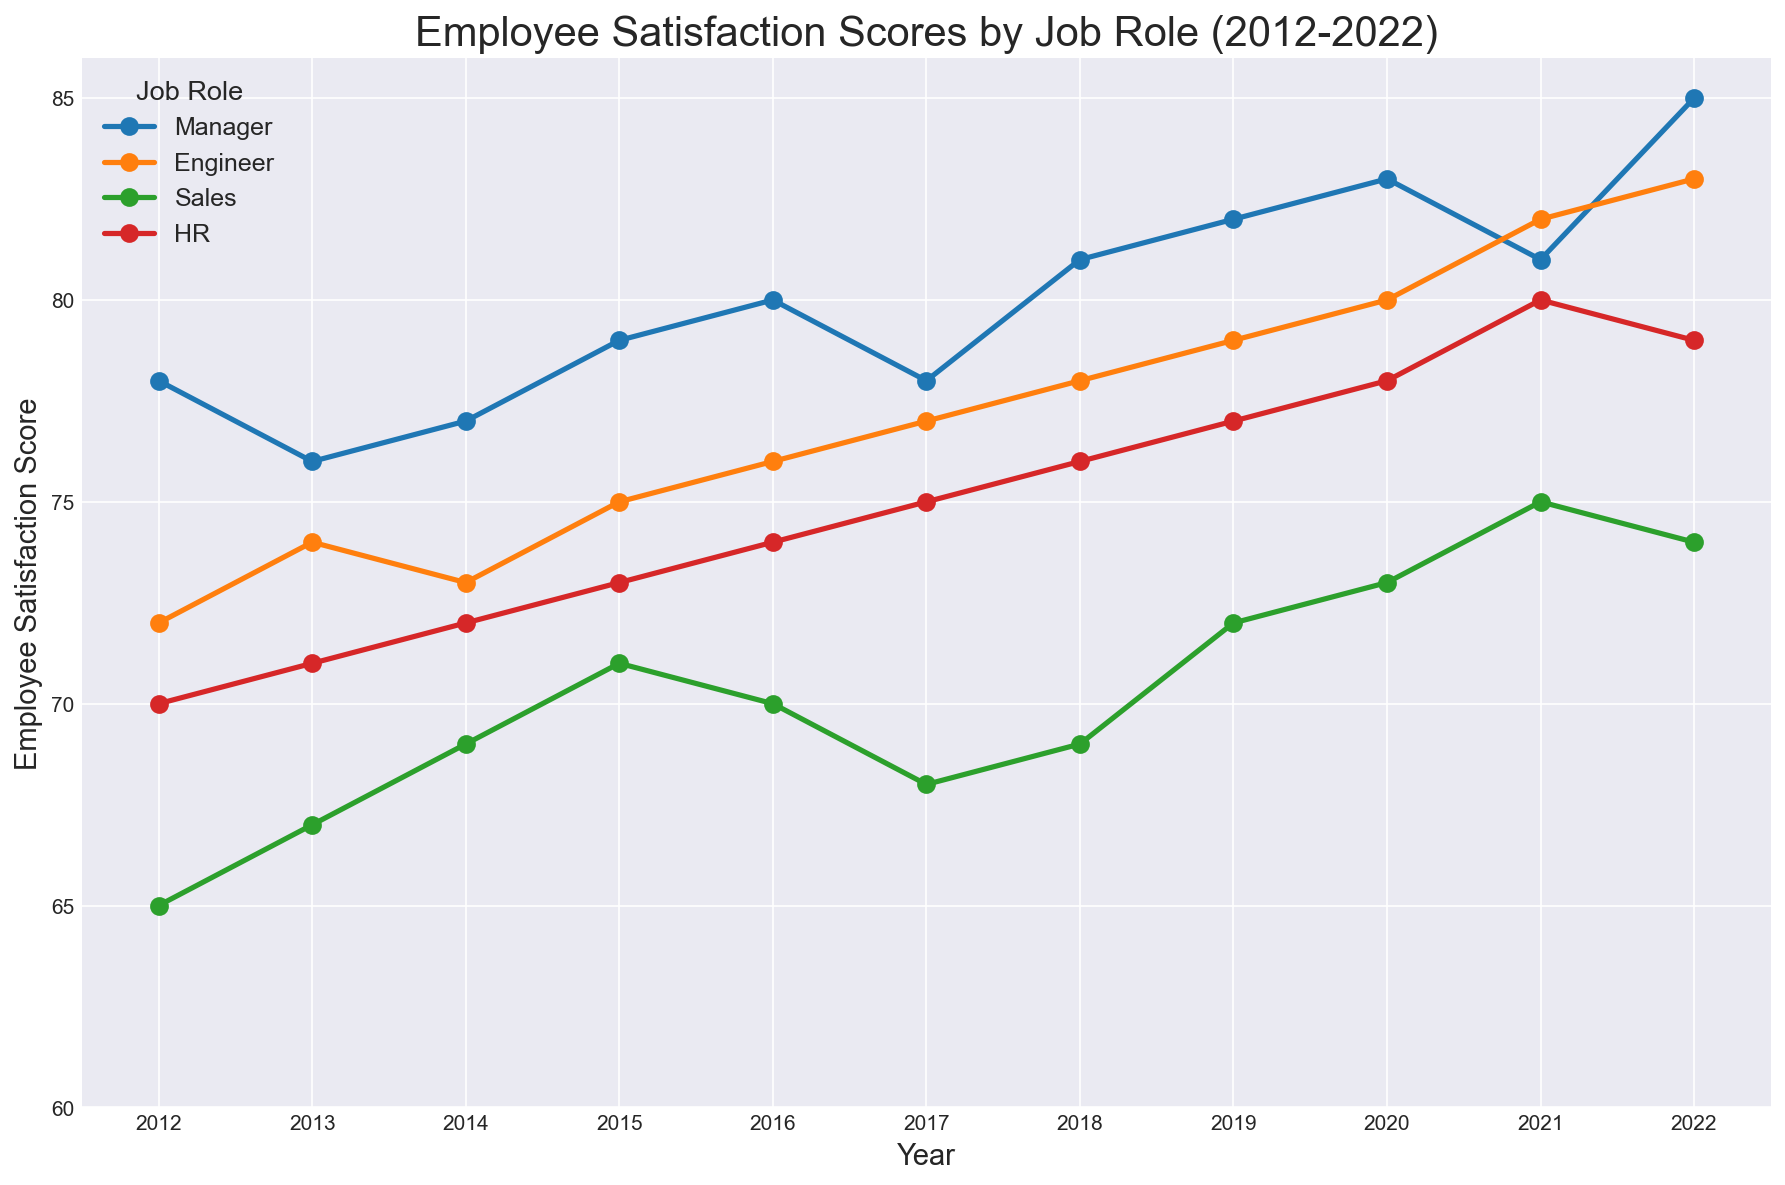What is the overall trend in Employee Satisfaction Scores for Engineers from 2012 to 2022? The visual trend line for Engineers shows a gradual increase in Employee Satisfaction Scores over the years from 72 in 2012 to 83 in 2022.
Answer: Gradual increase In which year did HR employees reach their highest satisfaction score? Observing the line, the highest point for HR employees is in the year 2021 with a score of 80.
Answer: 2021 Which job role had the highest Employee Satisfaction Score in 2022? The figure shows the Manager role closely reaching 85 in 2022, which is higher than any other job roles.
Answer: Manager How did the Employee Satisfaction Scores for Sales change from 2019 to 2022? The scores of Sales changed over the years, starting at 72 in 2019, increasing briefly to 73 in 2020, then rising again to 75 in 2021, but then dropped to 74 in 2022.
Answer: Increased initially, then dropped slightly By how much did the Employee Satisfaction Score for Engineers increase from 2017 to 2020? In 2017, the Engineers’ score is 77, and in 2020, it is 80. The increase is calculated as 80 - 77 = 3.
Answer: 3 Which job role showed the most significant improvement in Employee Satisfaction Scores from 2012 to 2022? By observing the slopes, Managers showed the most significant improvement from 78 in 2012 to 85 in 2022, which is an increase of 7.
Answer: Manager In what year did Sales employees experience a dip in their satisfaction score, and what was the score? Sales employees had a dip in their Employee Satisfaction Score in 2017, where the score decreased to 68.
Answer: 2017, 68 Compare the Employee Satisfaction Scores across all roles in 2021. Which job role had the closest scores in this year? In 2021, the scores are close for Engineer (82), HR (80), and Manager (81), but HR and Engineer had the closest scores at 80 and 82.
Answer: HR and Engineer What is the average Employee Satisfaction Score for HR employees over the entire period (2012–2022)? The average score is calculated by summing all HR scores listed and dividing them by the number of years. (70 + 71 + 72 + 73 + 74 + 75 + 76 + 77 + 78 + 80 + 79) = 825, and then 825/11 ≈ 75.
Answer: 75 Between Managers and Engineers, who had a higher Employee Satisfaction Score in 2016 and by how much? In 2016, Managers had a score of 80 and Engineers had a score of 76. The difference is 80 - 76 = 4.
Answer: Managers, by 4 